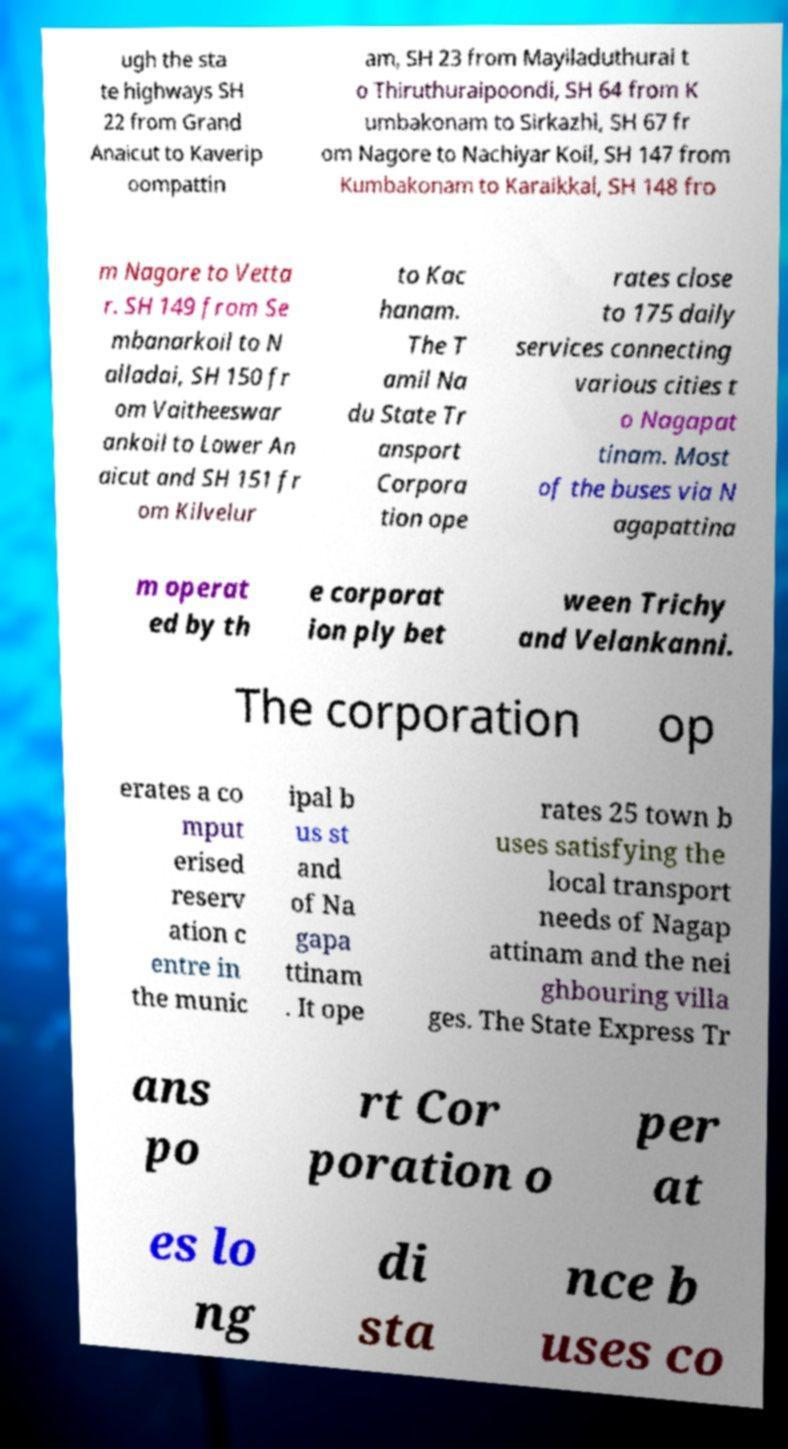Please identify and transcribe the text found in this image. ugh the sta te highways SH 22 from Grand Anaicut to Kaverip oompattin am, SH 23 from Mayiladuthurai t o Thiruthuraipoondi, SH 64 from K umbakonam to Sirkazhi, SH 67 fr om Nagore to Nachiyar Koil, SH 147 from Kumbakonam to Karaikkal, SH 148 fro m Nagore to Vetta r. SH 149 from Se mbanarkoil to N alladai, SH 150 fr om Vaitheeswar ankoil to Lower An aicut and SH 151 fr om Kilvelur to Kac hanam. The T amil Na du State Tr ansport Corpora tion ope rates close to 175 daily services connecting various cities t o Nagapat tinam. Most of the buses via N agapattina m operat ed by th e corporat ion ply bet ween Trichy and Velankanni. The corporation op erates a co mput erised reserv ation c entre in the munic ipal b us st and of Na gapa ttinam . It ope rates 25 town b uses satisfying the local transport needs of Nagap attinam and the nei ghbouring villa ges. The State Express Tr ans po rt Cor poration o per at es lo ng di sta nce b uses co 